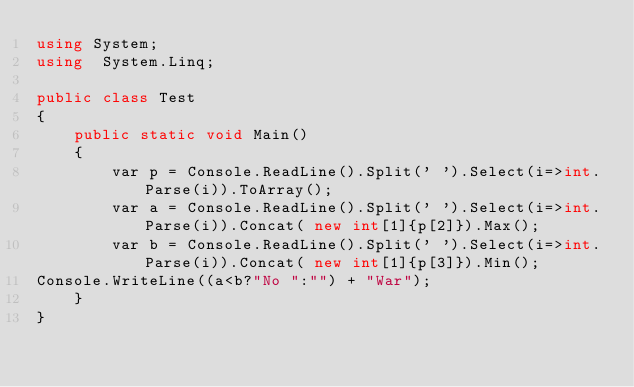Convert code to text. <code><loc_0><loc_0><loc_500><loc_500><_C#_>using System;
using  System.Linq;

public class Test
{
	public static void Main()
	{
		var p = Console.ReadLine().Split(' ').Select(i=>int.Parse(i)).ToArray();
		var a = Console.ReadLine().Split(' ').Select(i=>int.Parse(i)).Concat( new int[1]{p[2]}).Max();
		var b = Console.ReadLine().Split(' ').Select(i=>int.Parse(i)).Concat( new int[1]{p[3]}).Min();
Console.WriteLine((a<b?"No ":"") + "War");
	}
}</code> 